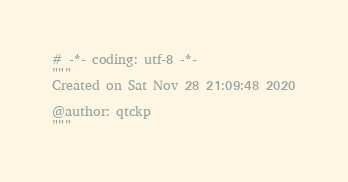Convert code to text. <code><loc_0><loc_0><loc_500><loc_500><_Python_># -*- coding: utf-8 -*-
"""
Created on Sat Nov 28 21:09:48 2020

@author: qtckp
"""
</code> 